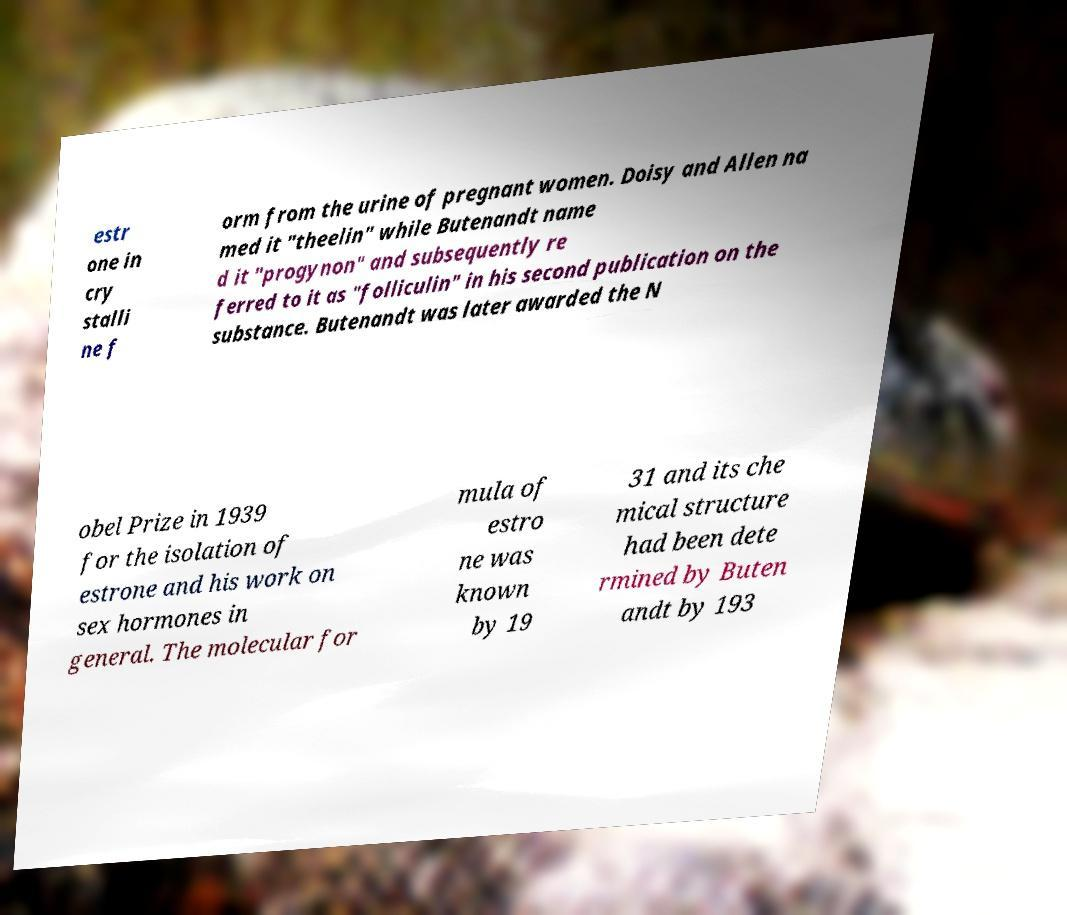There's text embedded in this image that I need extracted. Can you transcribe it verbatim? estr one in cry stalli ne f orm from the urine of pregnant women. Doisy and Allen na med it "theelin" while Butenandt name d it "progynon" and subsequently re ferred to it as "folliculin" in his second publication on the substance. Butenandt was later awarded the N obel Prize in 1939 for the isolation of estrone and his work on sex hormones in general. The molecular for mula of estro ne was known by 19 31 and its che mical structure had been dete rmined by Buten andt by 193 